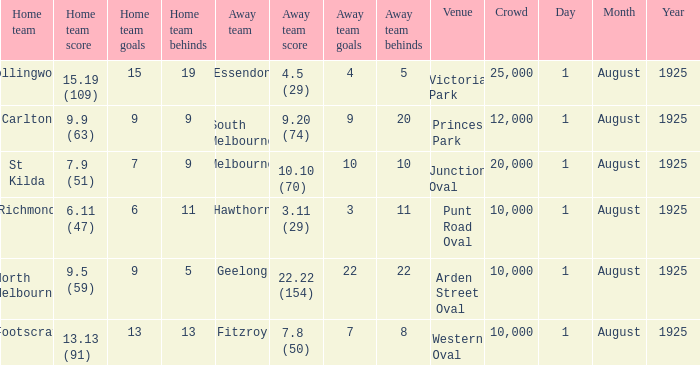Could you parse the entire table as a dict? {'header': ['Home team', 'Home team score', 'Home team goals', 'Home team behinds', 'Away team', 'Away team score', 'Away team goals', 'Away team behinds', 'Venue', 'Crowd', 'Day', 'Month', 'Year'], 'rows': [['Collingwood', '15.19 (109)', '15', '19', 'Essendon', '4.5 (29)', '4', '5', 'Victoria Park', '25,000', '1', 'August', '1925'], ['Carlton', '9.9 (63)', '9', '9', 'South Melbourne', '9.20 (74)', '9', '20', 'Princes Park', '12,000', '1', 'August', '1925'], ['St Kilda', '7.9 (51)', '7', '9', 'Melbourne', '10.10 (70)', '10', '10', 'Junction Oval', '20,000', '1', 'August', '1925'], ['Richmond', '6.11 (47)', '6', '11', 'Hawthorn', '3.11 (29)', '3', '11', 'Punt Road Oval', '10,000', '1', 'August', '1925'], ['North Melbourne', '9.5 (59)', '9', '5', 'Geelong', '22.22 (154)', '22', '22', 'Arden Street Oval', '10,000', '1', 'August', '1925'], ['Footscray', '13.13 (91)', '13', '13', 'Fitzroy', '7.8 (50)', '7', '8', 'Western Oval', '10,000', '1', 'August', '1925']]} Which team plays home at Princes Park? Carlton. 